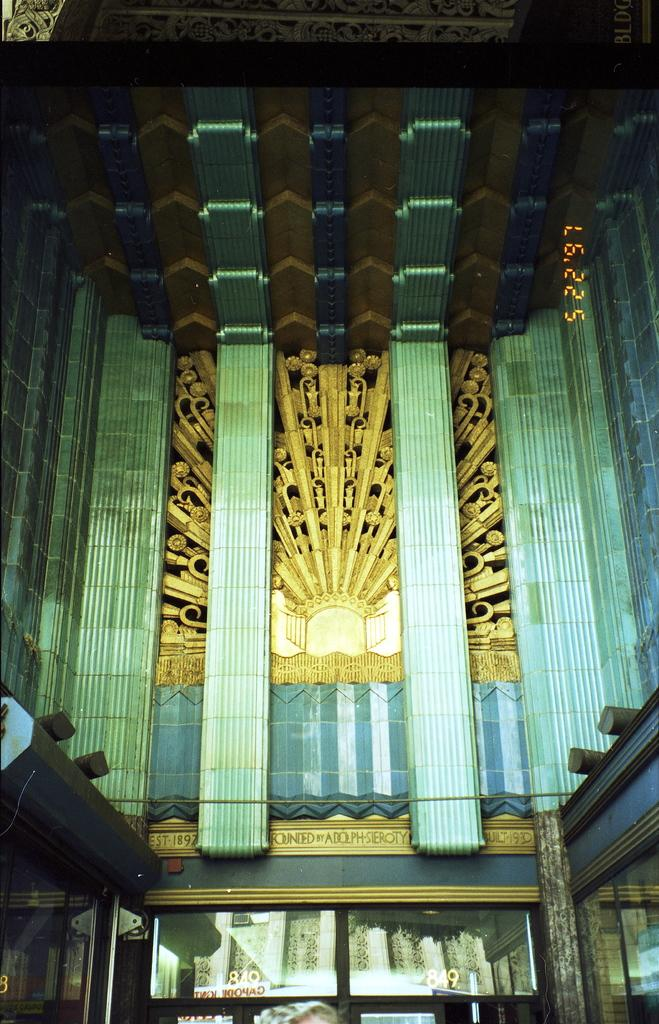What type of structure is in the image? There is a building in the image. What architectural feature can be seen on the building? The building has pillars. What is the purpose of the cable visible in the image? The purpose of the cable is not specified in the image, but it could be for electricity or communication. What device is present on the building for cooling? There is an air conditioner on the building. What can be seen through the windows of the building? The contents of the rooms or the view outside the building can be seen through the windows. What type of pet is visible in the image? There is no pet visible in the image; it features a building with pillars, a cable, an air conditioner, and windows. 